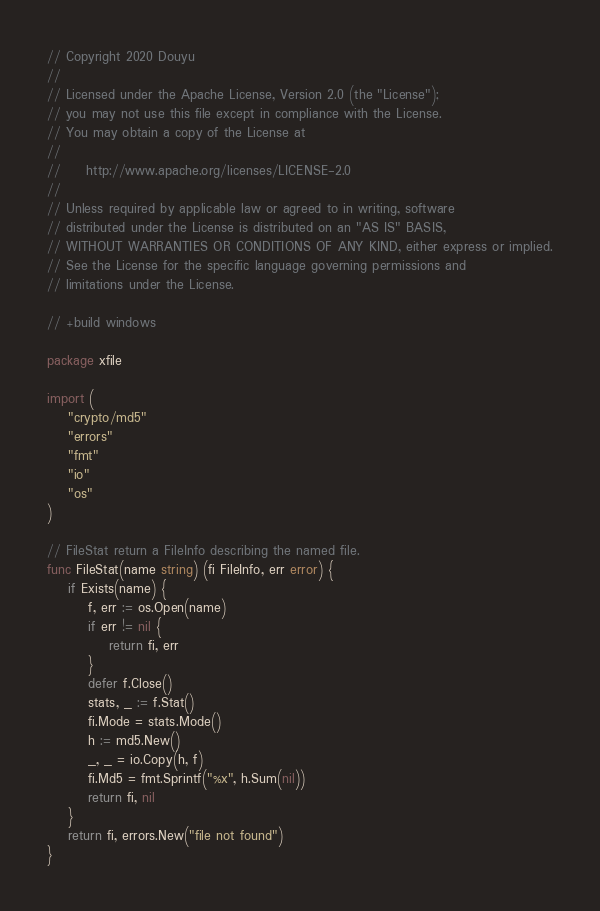Convert code to text. <code><loc_0><loc_0><loc_500><loc_500><_Go_>// Copyright 2020 Douyu
//
// Licensed under the Apache License, Version 2.0 (the "License");
// you may not use this file except in compliance with the License.
// You may obtain a copy of the License at
//
//     http://www.apache.org/licenses/LICENSE-2.0
//
// Unless required by applicable law or agreed to in writing, software
// distributed under the License is distributed on an "AS IS" BASIS,
// WITHOUT WARRANTIES OR CONDITIONS OF ANY KIND, either express or implied.
// See the License for the specific language governing permissions and
// limitations under the License.

// +build windows

package xfile

import (
	"crypto/md5"
	"errors"
	"fmt"
	"io"
	"os"
)

// FileStat return a FileInfo describing the named file.
func FileStat(name string) (fi FileInfo, err error) {
	if Exists(name) {
		f, err := os.Open(name)
		if err != nil {
			return fi, err
		}
		defer f.Close()
		stats, _ := f.Stat()
		fi.Mode = stats.Mode()
		h := md5.New()
		_, _ = io.Copy(h, f)
		fi.Md5 = fmt.Sprintf("%x", h.Sum(nil))
		return fi, nil
	}
	return fi, errors.New("file not found")
}
</code> 